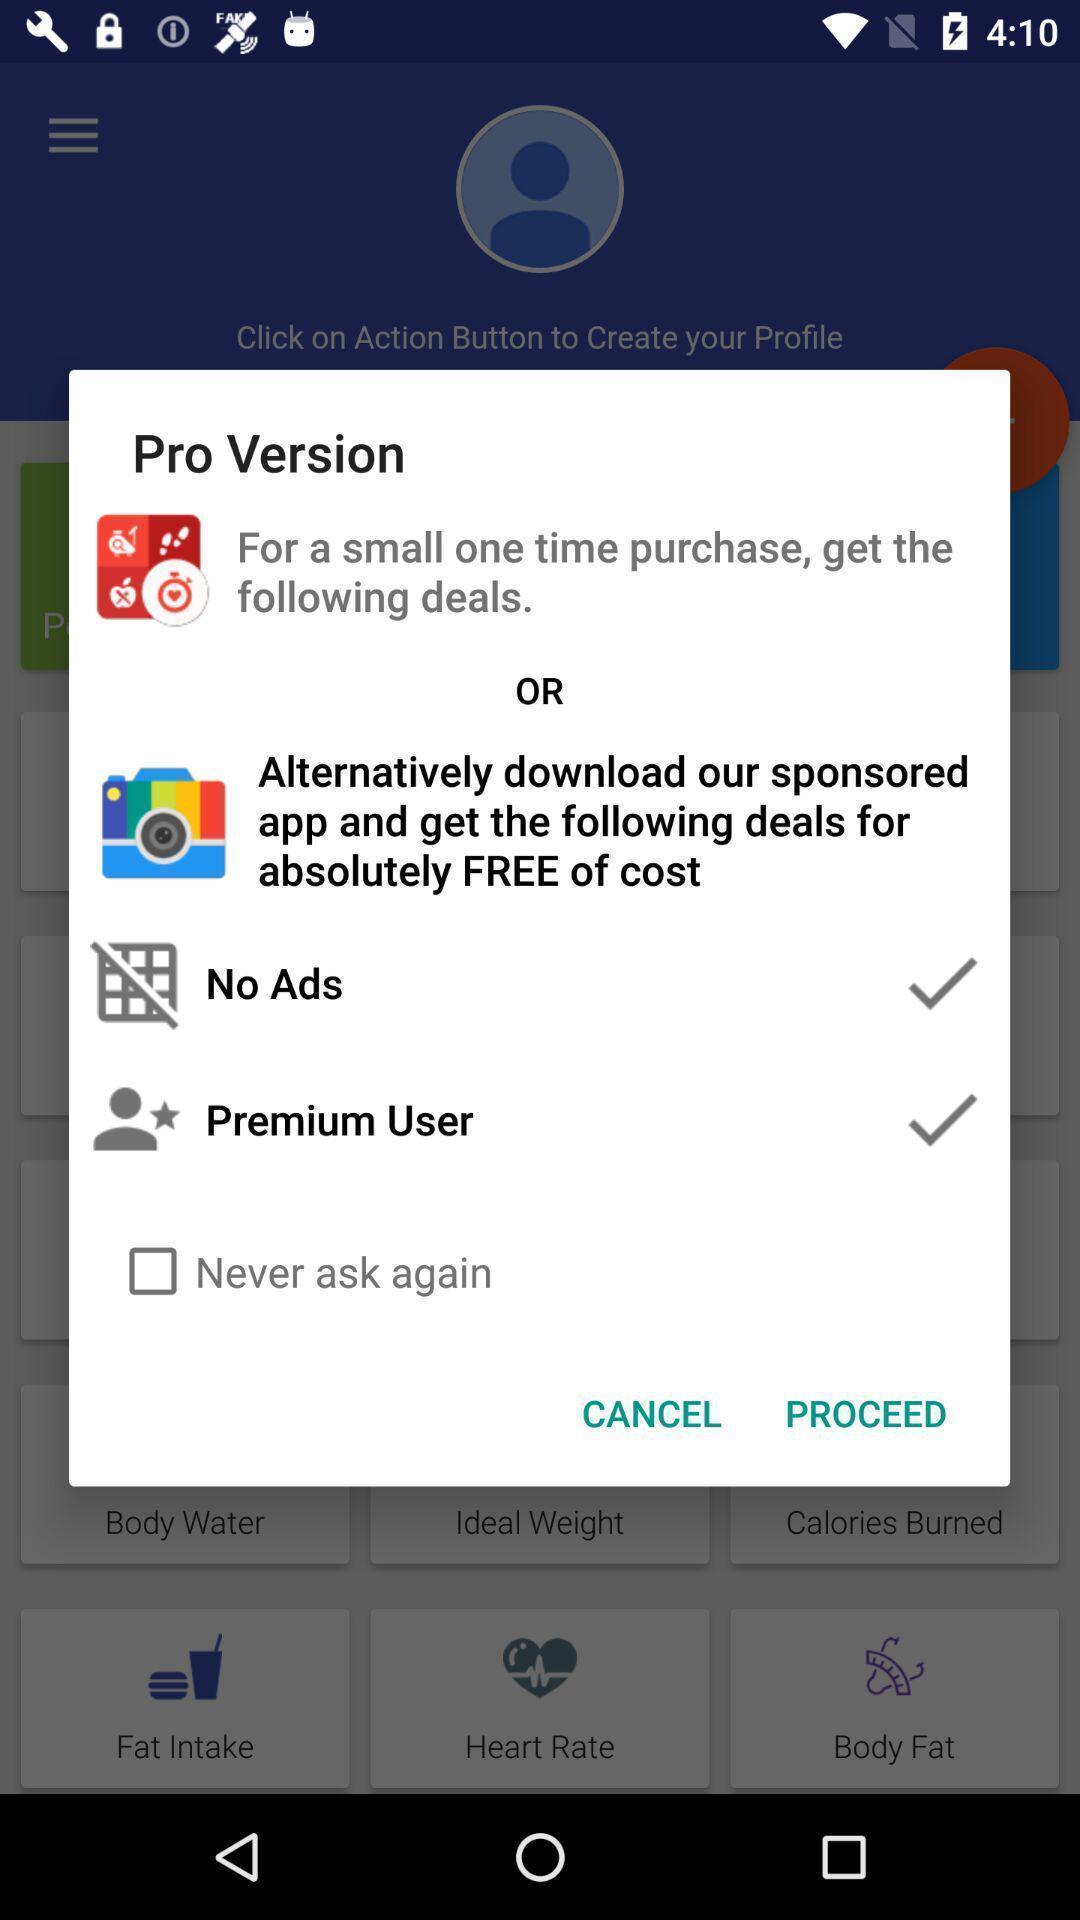What details can you identify in this image? Pop-up asking to proceed the application. 